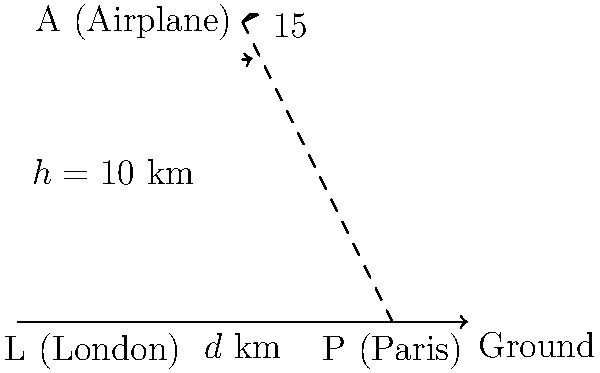As you fly from London to Paris, you observe the historical landscape that has shaped the relationship between these two significant European cities. From your airplane at an altitude of 10 km, you notice that the angle of depression to Paris is 15°. Using this information, calculate the distance between London and Paris. Round your answer to the nearest kilometer. To solve this problem, we'll use trigonometry, specifically the tangent function. Let's approach this step-by-step:

1) First, let's identify what we know:
   - The airplane's altitude ($h$) is 10 km
   - The angle of depression ($\theta$) is 15°
   - We need to find the distance ($d$) between London and Paris

2) In a right-angled triangle, tangent of an angle is the ratio of the opposite side to the adjacent side. Here, the altitude is opposite to the angle, and the distance we're looking for is adjacent.

3) We can express this relationship as:

   $\tan(\theta) = \frac{\text{opposite}}{\text{adjacent}} = \frac{h}{d}$

4) Substituting our known values:

   $\tan(15°) = \frac{10}{d}$

5) To solve for $d$, we multiply both sides by $d$:

   $d \tan(15°) = 10$

6) Then divide both sides by $\tan(15°)$:

   $d = \frac{10}{\tan(15°)}$

7) Now we can calculate this:
   $d = \frac{10}{\tan(15°)} \approx 37.32$ km

8) Rounding to the nearest kilometer:
   $d \approx 37$ km

This distance aligns with the historical context of the relatively close proximity between these two influential European capitals, which has played a significant role in their intertwined histories and the eventual development of the European Union, leading up to the complexities of Brexit.
Answer: 37 km 